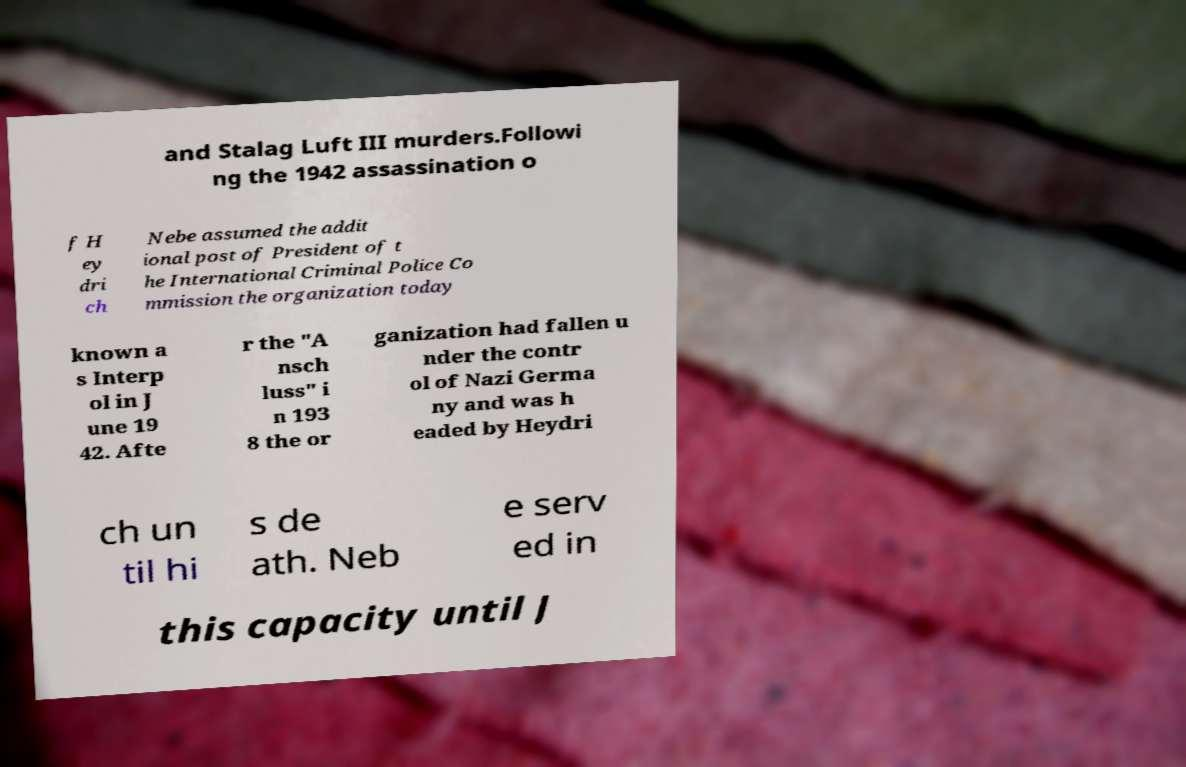Could you assist in decoding the text presented in this image and type it out clearly? and Stalag Luft III murders.Followi ng the 1942 assassination o f H ey dri ch Nebe assumed the addit ional post of President of t he International Criminal Police Co mmission the organization today known a s Interp ol in J une 19 42. Afte r the "A nsch luss" i n 193 8 the or ganization had fallen u nder the contr ol of Nazi Germa ny and was h eaded by Heydri ch un til hi s de ath. Neb e serv ed in this capacity until J 